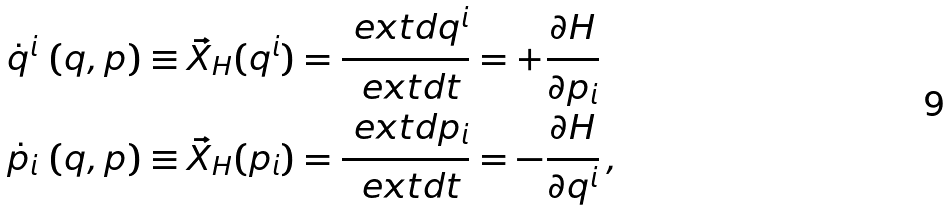<formula> <loc_0><loc_0><loc_500><loc_500>\dot { q } ^ { i } \, \left ( q , p \right ) & \equiv \vec { X } _ { H } ( q ^ { i } ) = \frac { \ e x t d q ^ { i } } { \ e x t d t } = + \frac { \partial H } { \partial p _ { i } } \\ \dot { p } _ { i } \, \left ( q , p \right ) & \equiv \vec { X } _ { H } ( p _ { i } ) = \frac { \ e x t d p _ { i } } { \ e x t d t } = - \frac { \partial H } { \partial q ^ { i } } \, ,</formula> 